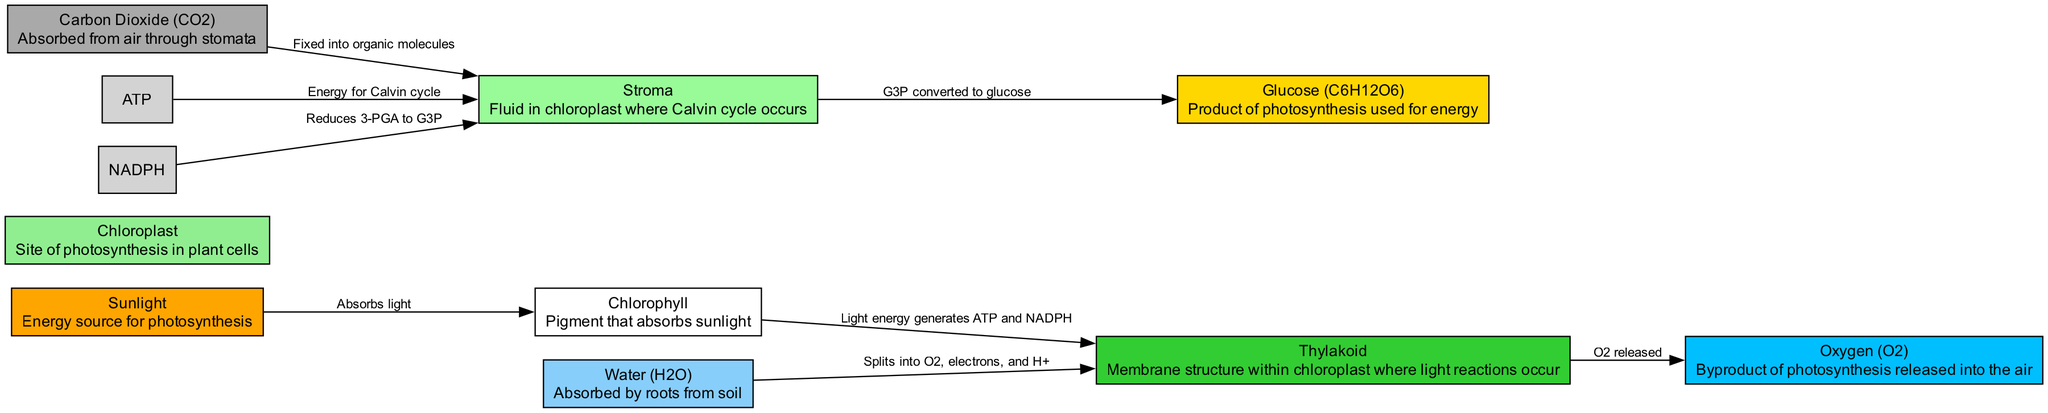What is the energy source for photosynthesis? The diagram identifies "Sunlight" as the energy source necessary for the process of photosynthesis, as indicated in the node description.
Answer: Sunlight Which gas is absorbed from the air? According to the diagram, "Carbon Dioxide (CO2)" is indicated as the gas that plants absorb from the air through stomata, as described in its node.
Answer: Carbon Dioxide (CO2) How many main products are generated from photosynthesis? From the connections in the diagram, namely "Oxygen" and "Glucose," we can count that there are two main products generated from photosynthesis.
Answer: 2 What byproduct is released during the photosynthesis process? The diagram shows that "Oxygen (O2)" is released as a byproduct during photosynthesis, based on the connections leading from the thylakoid to the oxygen node.
Answer: Oxygen (O2) What is the function of the thylakoid? The diagram states that "Thylakoid" is where light reactions occur, which generates ATP and NADPH, demonstrating its function during the process of photosynthesis.
Answer: Light reactions occur How does carbon dioxide enter the chloroplast? The diagram shows that "Carbon Dioxide (CO2)" is absorbed from the air through stomata and then fixed into organic molecules in the stroma, connecting these processes and indicating the entry into the chloroplast.
Answer: Absorbed through stomata What is produced from G3P in the Calvin cycle? The flow in the diagram indicates that G3P is converted to "Glucose" in the stroma, outlining the outcome of this process during the Calvin cycle.
Answer: Glucose Which component splits into oxygen, electrons, and H+? The diagram details that "Water (H2O)" is the component that splits into oxygen, electrons, and H+, as it connects to the thylakoid node illustrating this process.
Answer: Water (H2O) 